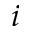<formula> <loc_0><loc_0><loc_500><loc_500>i</formula> 